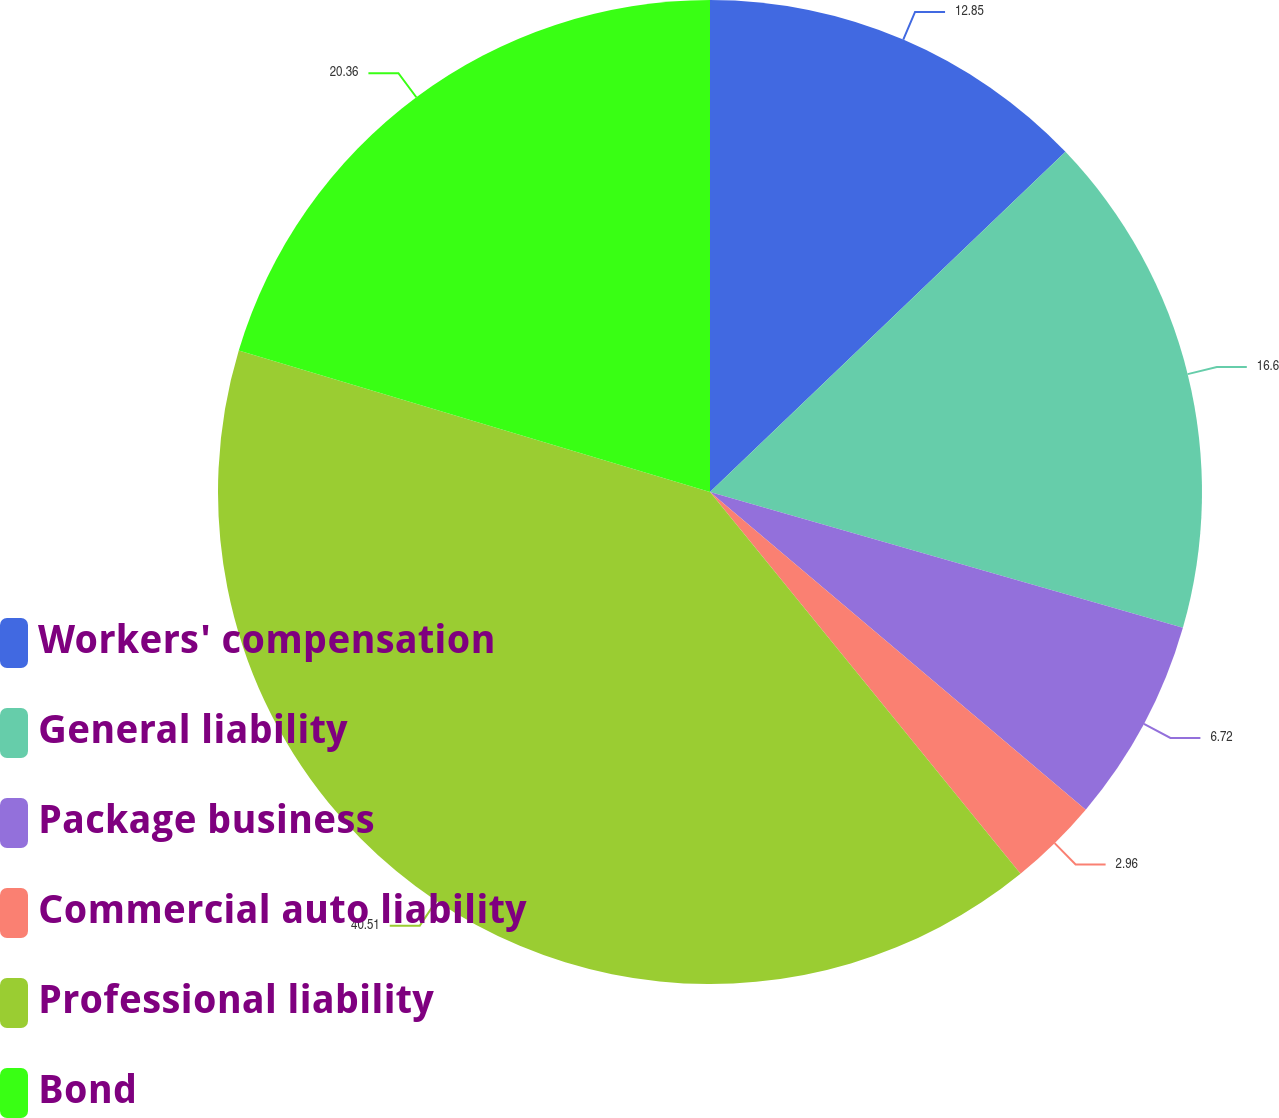<chart> <loc_0><loc_0><loc_500><loc_500><pie_chart><fcel>Workers' compensation<fcel>General liability<fcel>Package business<fcel>Commercial auto liability<fcel>Professional liability<fcel>Bond<nl><fcel>12.85%<fcel>16.6%<fcel>6.72%<fcel>2.96%<fcel>40.51%<fcel>20.36%<nl></chart> 